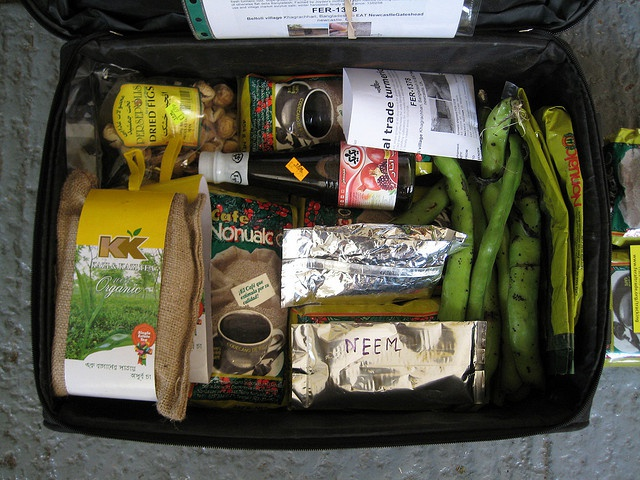Describe the objects in this image and their specific colors. I can see suitcase in black, olive, lightgray, and gray tones, bottle in black, darkgray, lightgray, and gray tones, and cup in black and gray tones in this image. 